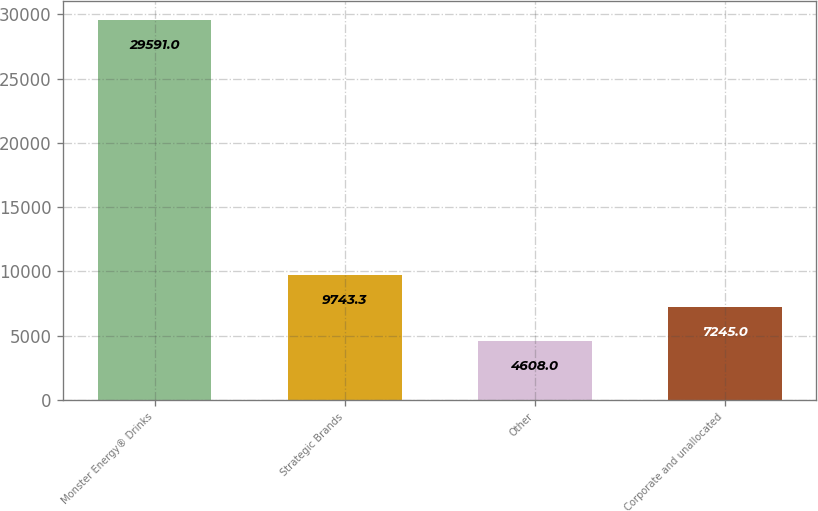Convert chart to OTSL. <chart><loc_0><loc_0><loc_500><loc_500><bar_chart><fcel>Monster Energy® Drinks<fcel>Strategic Brands<fcel>Other<fcel>Corporate and unallocated<nl><fcel>29591<fcel>9743.3<fcel>4608<fcel>7245<nl></chart> 